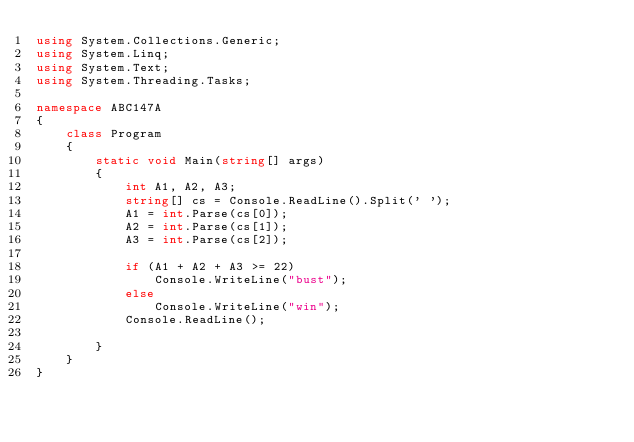<code> <loc_0><loc_0><loc_500><loc_500><_C#_>using System.Collections.Generic;
using System.Linq;
using System.Text;
using System.Threading.Tasks;

namespace ABC147A
{
    class Program
    {
        static void Main(string[] args)
        {
            int A1, A2, A3;
            string[] cs = Console.ReadLine().Split(' ');
            A1 = int.Parse(cs[0]);
            A2 = int.Parse(cs[1]);
            A3 = int.Parse(cs[2]);

            if (A1 + A2 + A3 >= 22)
                Console.WriteLine("bust");
            else 
                Console.WriteLine("win");
            Console.ReadLine();

        }
    }
}</code> 